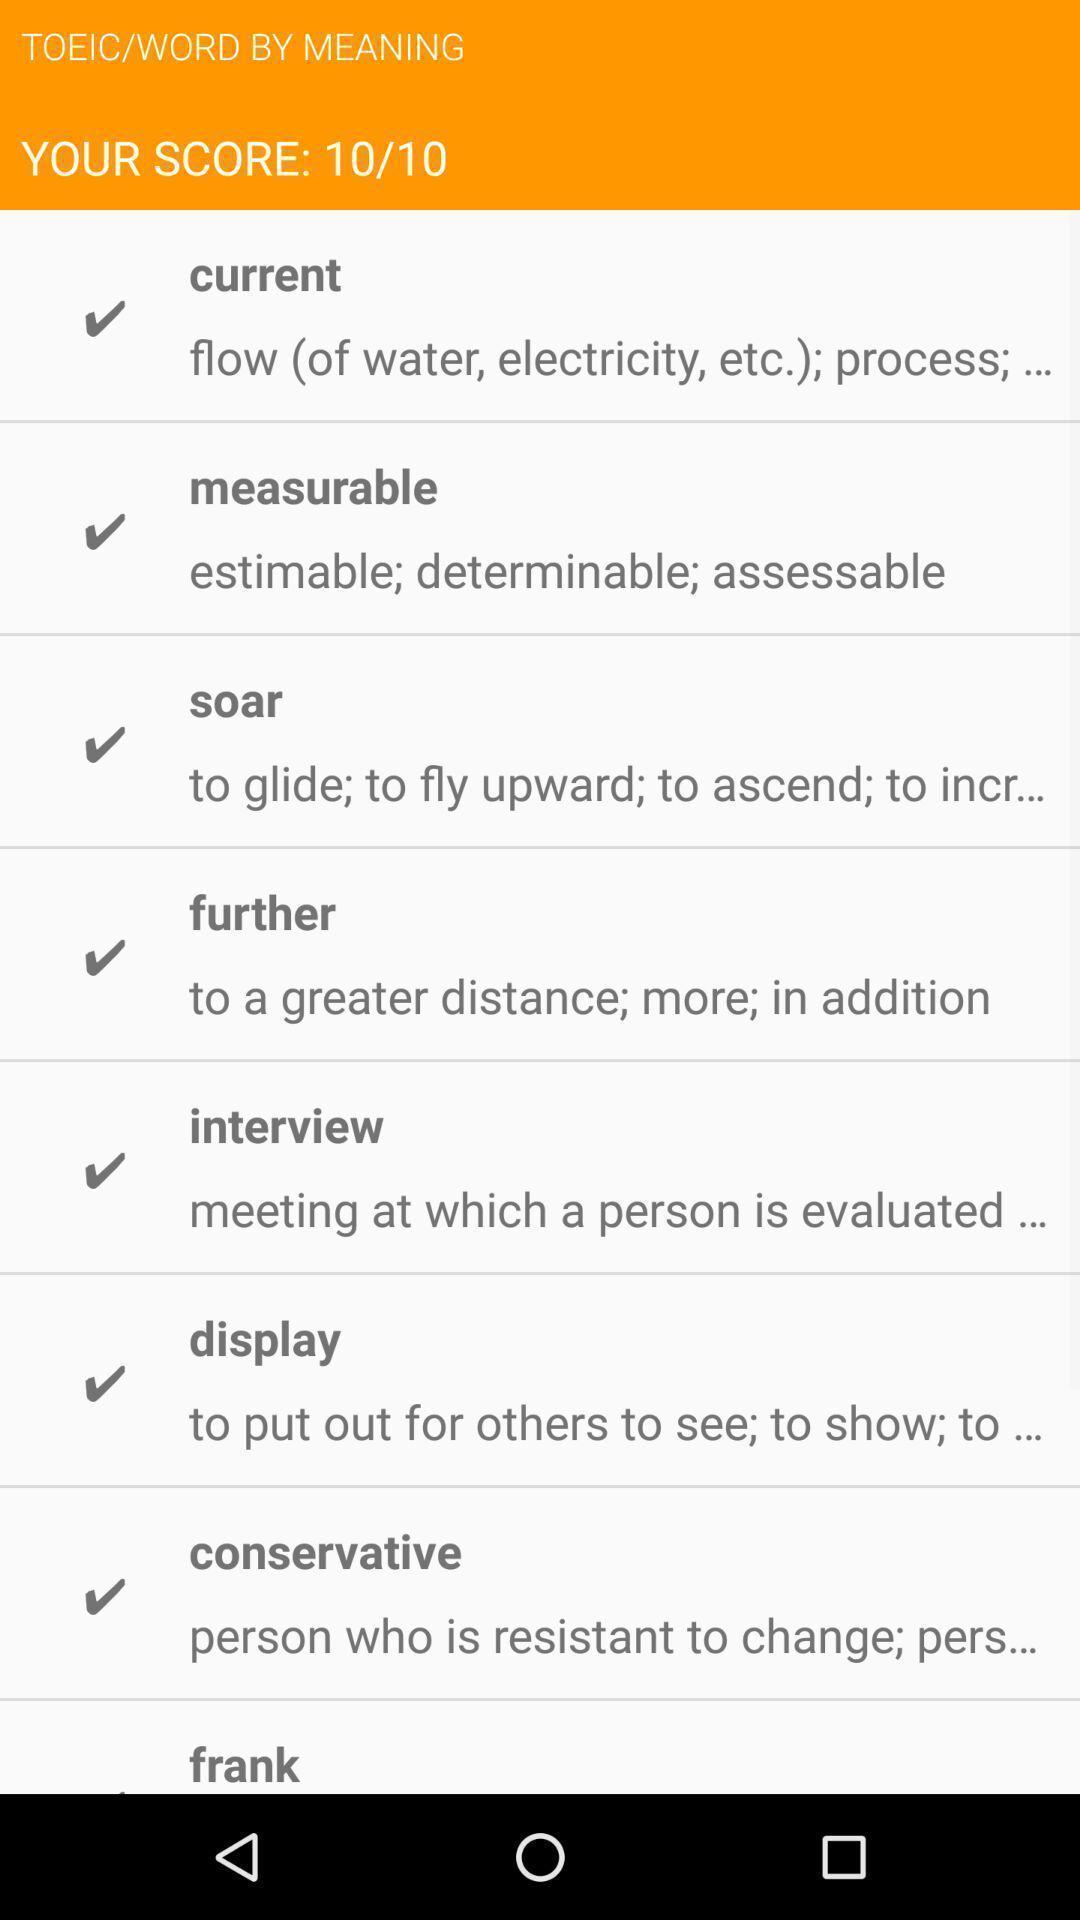Give me a narrative description of this picture. Your score screen with some information in language app. 